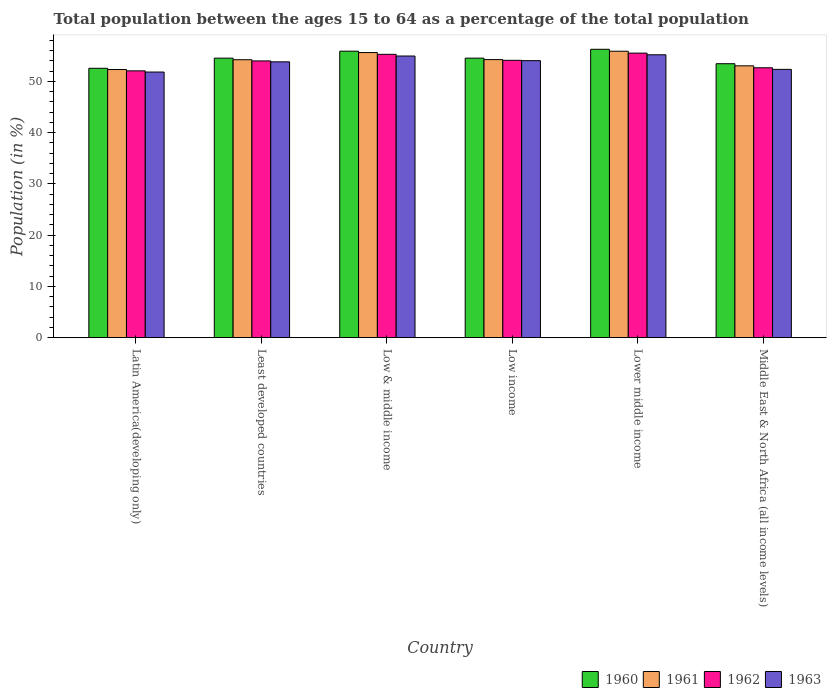How many different coloured bars are there?
Your answer should be very brief. 4. Are the number of bars on each tick of the X-axis equal?
Offer a terse response. Yes. What is the percentage of the population ages 15 to 64 in 1961 in Lower middle income?
Ensure brevity in your answer.  55.89. Across all countries, what is the maximum percentage of the population ages 15 to 64 in 1960?
Your response must be concise. 56.27. Across all countries, what is the minimum percentage of the population ages 15 to 64 in 1961?
Ensure brevity in your answer.  52.32. In which country was the percentage of the population ages 15 to 64 in 1960 maximum?
Your answer should be compact. Lower middle income. In which country was the percentage of the population ages 15 to 64 in 1961 minimum?
Offer a terse response. Latin America(developing only). What is the total percentage of the population ages 15 to 64 in 1961 in the graph?
Keep it short and to the point. 325.38. What is the difference between the percentage of the population ages 15 to 64 in 1960 in Latin America(developing only) and that in Least developed countries?
Your answer should be compact. -1.98. What is the difference between the percentage of the population ages 15 to 64 in 1962 in Low income and the percentage of the population ages 15 to 64 in 1960 in Least developed countries?
Your response must be concise. -0.43. What is the average percentage of the population ages 15 to 64 in 1962 per country?
Give a very brief answer. 53.94. What is the difference between the percentage of the population ages 15 to 64 of/in 1961 and percentage of the population ages 15 to 64 of/in 1960 in Low income?
Your answer should be compact. -0.28. In how many countries, is the percentage of the population ages 15 to 64 in 1960 greater than 30?
Provide a succinct answer. 6. What is the ratio of the percentage of the population ages 15 to 64 in 1961 in Latin America(developing only) to that in Low income?
Offer a very short reply. 0.96. Is the percentage of the population ages 15 to 64 in 1963 in Latin America(developing only) less than that in Lower middle income?
Your answer should be very brief. Yes. What is the difference between the highest and the second highest percentage of the population ages 15 to 64 in 1960?
Make the answer very short. 1.73. What is the difference between the highest and the lowest percentage of the population ages 15 to 64 in 1961?
Your answer should be compact. 3.57. In how many countries, is the percentage of the population ages 15 to 64 in 1960 greater than the average percentage of the population ages 15 to 64 in 1960 taken over all countries?
Provide a succinct answer. 2. What does the 3rd bar from the right in Low income represents?
Ensure brevity in your answer.  1961. Are all the bars in the graph horizontal?
Offer a very short reply. No. How many countries are there in the graph?
Give a very brief answer. 6. What is the difference between two consecutive major ticks on the Y-axis?
Your answer should be compact. 10. Are the values on the major ticks of Y-axis written in scientific E-notation?
Your answer should be compact. No. Does the graph contain any zero values?
Provide a short and direct response. No. Does the graph contain grids?
Make the answer very short. No. Where does the legend appear in the graph?
Your response must be concise. Bottom right. How are the legend labels stacked?
Ensure brevity in your answer.  Horizontal. What is the title of the graph?
Ensure brevity in your answer.  Total population between the ages 15 to 64 as a percentage of the total population. Does "1961" appear as one of the legend labels in the graph?
Give a very brief answer. Yes. What is the label or title of the X-axis?
Offer a terse response. Country. What is the label or title of the Y-axis?
Give a very brief answer. Population (in %). What is the Population (in %) of 1960 in Latin America(developing only)?
Ensure brevity in your answer.  52.56. What is the Population (in %) in 1961 in Latin America(developing only)?
Offer a terse response. 52.32. What is the Population (in %) in 1962 in Latin America(developing only)?
Keep it short and to the point. 52.06. What is the Population (in %) in 1963 in Latin America(developing only)?
Your answer should be compact. 51.83. What is the Population (in %) of 1960 in Least developed countries?
Ensure brevity in your answer.  54.54. What is the Population (in %) in 1961 in Least developed countries?
Give a very brief answer. 54.24. What is the Population (in %) of 1962 in Least developed countries?
Your answer should be compact. 54. What is the Population (in %) of 1963 in Least developed countries?
Your answer should be compact. 53.82. What is the Population (in %) in 1960 in Low & middle income?
Your response must be concise. 55.9. What is the Population (in %) of 1961 in Low & middle income?
Your response must be concise. 55.63. What is the Population (in %) of 1962 in Low & middle income?
Give a very brief answer. 55.29. What is the Population (in %) in 1963 in Low & middle income?
Provide a short and direct response. 54.96. What is the Population (in %) in 1960 in Low income?
Offer a very short reply. 54.54. What is the Population (in %) of 1961 in Low income?
Ensure brevity in your answer.  54.26. What is the Population (in %) of 1962 in Low income?
Give a very brief answer. 54.11. What is the Population (in %) in 1963 in Low income?
Your answer should be very brief. 54.06. What is the Population (in %) in 1960 in Lower middle income?
Keep it short and to the point. 56.27. What is the Population (in %) of 1961 in Lower middle income?
Your answer should be compact. 55.89. What is the Population (in %) of 1962 in Lower middle income?
Give a very brief answer. 55.53. What is the Population (in %) in 1963 in Lower middle income?
Your answer should be very brief. 55.2. What is the Population (in %) in 1960 in Middle East & North Africa (all income levels)?
Provide a short and direct response. 53.46. What is the Population (in %) in 1961 in Middle East & North Africa (all income levels)?
Give a very brief answer. 53.04. What is the Population (in %) of 1962 in Middle East & North Africa (all income levels)?
Provide a succinct answer. 52.67. What is the Population (in %) of 1963 in Middle East & North Africa (all income levels)?
Give a very brief answer. 52.35. Across all countries, what is the maximum Population (in %) of 1960?
Offer a terse response. 56.27. Across all countries, what is the maximum Population (in %) in 1961?
Offer a very short reply. 55.89. Across all countries, what is the maximum Population (in %) in 1962?
Your answer should be compact. 55.53. Across all countries, what is the maximum Population (in %) in 1963?
Your answer should be compact. 55.2. Across all countries, what is the minimum Population (in %) in 1960?
Make the answer very short. 52.56. Across all countries, what is the minimum Population (in %) of 1961?
Give a very brief answer. 52.32. Across all countries, what is the minimum Population (in %) of 1962?
Offer a terse response. 52.06. Across all countries, what is the minimum Population (in %) of 1963?
Your response must be concise. 51.83. What is the total Population (in %) of 1960 in the graph?
Give a very brief answer. 327.28. What is the total Population (in %) of 1961 in the graph?
Your response must be concise. 325.38. What is the total Population (in %) of 1962 in the graph?
Offer a terse response. 323.65. What is the total Population (in %) of 1963 in the graph?
Offer a terse response. 322.22. What is the difference between the Population (in %) of 1960 in Latin America(developing only) and that in Least developed countries?
Offer a terse response. -1.98. What is the difference between the Population (in %) of 1961 in Latin America(developing only) and that in Least developed countries?
Your response must be concise. -1.91. What is the difference between the Population (in %) of 1962 in Latin America(developing only) and that in Least developed countries?
Your answer should be very brief. -1.94. What is the difference between the Population (in %) of 1963 in Latin America(developing only) and that in Least developed countries?
Keep it short and to the point. -1.99. What is the difference between the Population (in %) of 1960 in Latin America(developing only) and that in Low & middle income?
Offer a terse response. -3.34. What is the difference between the Population (in %) in 1961 in Latin America(developing only) and that in Low & middle income?
Provide a short and direct response. -3.31. What is the difference between the Population (in %) in 1962 in Latin America(developing only) and that in Low & middle income?
Offer a very short reply. -3.22. What is the difference between the Population (in %) in 1963 in Latin America(developing only) and that in Low & middle income?
Offer a very short reply. -3.13. What is the difference between the Population (in %) of 1960 in Latin America(developing only) and that in Low income?
Provide a short and direct response. -1.98. What is the difference between the Population (in %) of 1961 in Latin America(developing only) and that in Low income?
Give a very brief answer. -1.94. What is the difference between the Population (in %) in 1962 in Latin America(developing only) and that in Low income?
Offer a terse response. -2.05. What is the difference between the Population (in %) in 1963 in Latin America(developing only) and that in Low income?
Offer a terse response. -2.22. What is the difference between the Population (in %) in 1960 in Latin America(developing only) and that in Lower middle income?
Give a very brief answer. -3.71. What is the difference between the Population (in %) of 1961 in Latin America(developing only) and that in Lower middle income?
Offer a very short reply. -3.57. What is the difference between the Population (in %) of 1962 in Latin America(developing only) and that in Lower middle income?
Ensure brevity in your answer.  -3.46. What is the difference between the Population (in %) of 1963 in Latin America(developing only) and that in Lower middle income?
Provide a short and direct response. -3.37. What is the difference between the Population (in %) in 1960 in Latin America(developing only) and that in Middle East & North Africa (all income levels)?
Offer a terse response. -0.89. What is the difference between the Population (in %) of 1961 in Latin America(developing only) and that in Middle East & North Africa (all income levels)?
Your answer should be very brief. -0.72. What is the difference between the Population (in %) of 1962 in Latin America(developing only) and that in Middle East & North Africa (all income levels)?
Give a very brief answer. -0.6. What is the difference between the Population (in %) of 1963 in Latin America(developing only) and that in Middle East & North Africa (all income levels)?
Ensure brevity in your answer.  -0.52. What is the difference between the Population (in %) in 1960 in Least developed countries and that in Low & middle income?
Ensure brevity in your answer.  -1.36. What is the difference between the Population (in %) of 1961 in Least developed countries and that in Low & middle income?
Provide a short and direct response. -1.39. What is the difference between the Population (in %) of 1962 in Least developed countries and that in Low & middle income?
Your answer should be compact. -1.29. What is the difference between the Population (in %) of 1963 in Least developed countries and that in Low & middle income?
Offer a terse response. -1.13. What is the difference between the Population (in %) in 1960 in Least developed countries and that in Low income?
Offer a very short reply. 0. What is the difference between the Population (in %) of 1961 in Least developed countries and that in Low income?
Offer a very short reply. -0.02. What is the difference between the Population (in %) in 1962 in Least developed countries and that in Low income?
Give a very brief answer. -0.12. What is the difference between the Population (in %) in 1963 in Least developed countries and that in Low income?
Keep it short and to the point. -0.23. What is the difference between the Population (in %) of 1960 in Least developed countries and that in Lower middle income?
Your answer should be compact. -1.73. What is the difference between the Population (in %) in 1961 in Least developed countries and that in Lower middle income?
Make the answer very short. -1.66. What is the difference between the Population (in %) of 1962 in Least developed countries and that in Lower middle income?
Provide a succinct answer. -1.53. What is the difference between the Population (in %) of 1963 in Least developed countries and that in Lower middle income?
Make the answer very short. -1.38. What is the difference between the Population (in %) in 1960 in Least developed countries and that in Middle East & North Africa (all income levels)?
Your response must be concise. 1.09. What is the difference between the Population (in %) of 1961 in Least developed countries and that in Middle East & North Africa (all income levels)?
Give a very brief answer. 1.19. What is the difference between the Population (in %) in 1962 in Least developed countries and that in Middle East & North Africa (all income levels)?
Your answer should be very brief. 1.33. What is the difference between the Population (in %) of 1963 in Least developed countries and that in Middle East & North Africa (all income levels)?
Offer a very short reply. 1.47. What is the difference between the Population (in %) of 1960 in Low & middle income and that in Low income?
Your response must be concise. 1.36. What is the difference between the Population (in %) of 1961 in Low & middle income and that in Low income?
Your answer should be very brief. 1.37. What is the difference between the Population (in %) of 1962 in Low & middle income and that in Low income?
Your answer should be compact. 1.17. What is the difference between the Population (in %) in 1963 in Low & middle income and that in Low income?
Provide a short and direct response. 0.9. What is the difference between the Population (in %) in 1960 in Low & middle income and that in Lower middle income?
Provide a succinct answer. -0.37. What is the difference between the Population (in %) of 1961 in Low & middle income and that in Lower middle income?
Your response must be concise. -0.26. What is the difference between the Population (in %) of 1962 in Low & middle income and that in Lower middle income?
Provide a short and direct response. -0.24. What is the difference between the Population (in %) of 1963 in Low & middle income and that in Lower middle income?
Provide a short and direct response. -0.24. What is the difference between the Population (in %) of 1960 in Low & middle income and that in Middle East & North Africa (all income levels)?
Provide a short and direct response. 2.45. What is the difference between the Population (in %) of 1961 in Low & middle income and that in Middle East & North Africa (all income levels)?
Offer a terse response. 2.59. What is the difference between the Population (in %) in 1962 in Low & middle income and that in Middle East & North Africa (all income levels)?
Give a very brief answer. 2.62. What is the difference between the Population (in %) of 1963 in Low & middle income and that in Middle East & North Africa (all income levels)?
Your response must be concise. 2.6. What is the difference between the Population (in %) in 1960 in Low income and that in Lower middle income?
Give a very brief answer. -1.73. What is the difference between the Population (in %) in 1961 in Low income and that in Lower middle income?
Your answer should be compact. -1.63. What is the difference between the Population (in %) in 1962 in Low income and that in Lower middle income?
Offer a very short reply. -1.41. What is the difference between the Population (in %) in 1963 in Low income and that in Lower middle income?
Keep it short and to the point. -1.14. What is the difference between the Population (in %) of 1960 in Low income and that in Middle East & North Africa (all income levels)?
Your response must be concise. 1.08. What is the difference between the Population (in %) in 1961 in Low income and that in Middle East & North Africa (all income levels)?
Give a very brief answer. 1.22. What is the difference between the Population (in %) in 1962 in Low income and that in Middle East & North Africa (all income levels)?
Provide a succinct answer. 1.45. What is the difference between the Population (in %) of 1963 in Low income and that in Middle East & North Africa (all income levels)?
Provide a short and direct response. 1.7. What is the difference between the Population (in %) in 1960 in Lower middle income and that in Middle East & North Africa (all income levels)?
Offer a very short reply. 2.81. What is the difference between the Population (in %) of 1961 in Lower middle income and that in Middle East & North Africa (all income levels)?
Provide a short and direct response. 2.85. What is the difference between the Population (in %) in 1962 in Lower middle income and that in Middle East & North Africa (all income levels)?
Ensure brevity in your answer.  2.86. What is the difference between the Population (in %) of 1963 in Lower middle income and that in Middle East & North Africa (all income levels)?
Your answer should be very brief. 2.85. What is the difference between the Population (in %) of 1960 in Latin America(developing only) and the Population (in %) of 1961 in Least developed countries?
Provide a succinct answer. -1.67. What is the difference between the Population (in %) of 1960 in Latin America(developing only) and the Population (in %) of 1962 in Least developed countries?
Your answer should be very brief. -1.44. What is the difference between the Population (in %) of 1960 in Latin America(developing only) and the Population (in %) of 1963 in Least developed countries?
Your response must be concise. -1.26. What is the difference between the Population (in %) in 1961 in Latin America(developing only) and the Population (in %) in 1962 in Least developed countries?
Ensure brevity in your answer.  -1.68. What is the difference between the Population (in %) in 1961 in Latin America(developing only) and the Population (in %) in 1963 in Least developed countries?
Keep it short and to the point. -1.5. What is the difference between the Population (in %) in 1962 in Latin America(developing only) and the Population (in %) in 1963 in Least developed countries?
Your response must be concise. -1.76. What is the difference between the Population (in %) of 1960 in Latin America(developing only) and the Population (in %) of 1961 in Low & middle income?
Give a very brief answer. -3.07. What is the difference between the Population (in %) in 1960 in Latin America(developing only) and the Population (in %) in 1962 in Low & middle income?
Your response must be concise. -2.72. What is the difference between the Population (in %) of 1960 in Latin America(developing only) and the Population (in %) of 1963 in Low & middle income?
Provide a succinct answer. -2.39. What is the difference between the Population (in %) of 1961 in Latin America(developing only) and the Population (in %) of 1962 in Low & middle income?
Ensure brevity in your answer.  -2.96. What is the difference between the Population (in %) of 1961 in Latin America(developing only) and the Population (in %) of 1963 in Low & middle income?
Offer a terse response. -2.63. What is the difference between the Population (in %) of 1962 in Latin America(developing only) and the Population (in %) of 1963 in Low & middle income?
Provide a short and direct response. -2.89. What is the difference between the Population (in %) in 1960 in Latin America(developing only) and the Population (in %) in 1961 in Low income?
Offer a very short reply. -1.7. What is the difference between the Population (in %) of 1960 in Latin America(developing only) and the Population (in %) of 1962 in Low income?
Ensure brevity in your answer.  -1.55. What is the difference between the Population (in %) in 1960 in Latin America(developing only) and the Population (in %) in 1963 in Low income?
Ensure brevity in your answer.  -1.49. What is the difference between the Population (in %) of 1961 in Latin America(developing only) and the Population (in %) of 1962 in Low income?
Your answer should be compact. -1.79. What is the difference between the Population (in %) in 1961 in Latin America(developing only) and the Population (in %) in 1963 in Low income?
Provide a short and direct response. -1.73. What is the difference between the Population (in %) of 1962 in Latin America(developing only) and the Population (in %) of 1963 in Low income?
Offer a terse response. -1.99. What is the difference between the Population (in %) of 1960 in Latin America(developing only) and the Population (in %) of 1961 in Lower middle income?
Your answer should be very brief. -3.33. What is the difference between the Population (in %) of 1960 in Latin America(developing only) and the Population (in %) of 1962 in Lower middle income?
Offer a very short reply. -2.96. What is the difference between the Population (in %) of 1960 in Latin America(developing only) and the Population (in %) of 1963 in Lower middle income?
Keep it short and to the point. -2.64. What is the difference between the Population (in %) of 1961 in Latin America(developing only) and the Population (in %) of 1962 in Lower middle income?
Give a very brief answer. -3.2. What is the difference between the Population (in %) of 1961 in Latin America(developing only) and the Population (in %) of 1963 in Lower middle income?
Offer a terse response. -2.88. What is the difference between the Population (in %) in 1962 in Latin America(developing only) and the Population (in %) in 1963 in Lower middle income?
Offer a very short reply. -3.14. What is the difference between the Population (in %) in 1960 in Latin America(developing only) and the Population (in %) in 1961 in Middle East & North Africa (all income levels)?
Offer a terse response. -0.48. What is the difference between the Population (in %) of 1960 in Latin America(developing only) and the Population (in %) of 1962 in Middle East & North Africa (all income levels)?
Keep it short and to the point. -0.1. What is the difference between the Population (in %) of 1960 in Latin America(developing only) and the Population (in %) of 1963 in Middle East & North Africa (all income levels)?
Your answer should be very brief. 0.21. What is the difference between the Population (in %) of 1961 in Latin America(developing only) and the Population (in %) of 1962 in Middle East & North Africa (all income levels)?
Your response must be concise. -0.34. What is the difference between the Population (in %) in 1961 in Latin America(developing only) and the Population (in %) in 1963 in Middle East & North Africa (all income levels)?
Offer a very short reply. -0.03. What is the difference between the Population (in %) of 1962 in Latin America(developing only) and the Population (in %) of 1963 in Middle East & North Africa (all income levels)?
Your answer should be very brief. -0.29. What is the difference between the Population (in %) of 1960 in Least developed countries and the Population (in %) of 1961 in Low & middle income?
Your response must be concise. -1.09. What is the difference between the Population (in %) in 1960 in Least developed countries and the Population (in %) in 1962 in Low & middle income?
Your answer should be very brief. -0.74. What is the difference between the Population (in %) in 1960 in Least developed countries and the Population (in %) in 1963 in Low & middle income?
Offer a very short reply. -0.42. What is the difference between the Population (in %) in 1961 in Least developed countries and the Population (in %) in 1962 in Low & middle income?
Offer a terse response. -1.05. What is the difference between the Population (in %) in 1961 in Least developed countries and the Population (in %) in 1963 in Low & middle income?
Your answer should be very brief. -0.72. What is the difference between the Population (in %) in 1962 in Least developed countries and the Population (in %) in 1963 in Low & middle income?
Provide a short and direct response. -0.96. What is the difference between the Population (in %) of 1960 in Least developed countries and the Population (in %) of 1961 in Low income?
Ensure brevity in your answer.  0.28. What is the difference between the Population (in %) in 1960 in Least developed countries and the Population (in %) in 1962 in Low income?
Make the answer very short. 0.43. What is the difference between the Population (in %) of 1960 in Least developed countries and the Population (in %) of 1963 in Low income?
Your answer should be very brief. 0.49. What is the difference between the Population (in %) of 1961 in Least developed countries and the Population (in %) of 1962 in Low income?
Provide a succinct answer. 0.12. What is the difference between the Population (in %) in 1961 in Least developed countries and the Population (in %) in 1963 in Low income?
Ensure brevity in your answer.  0.18. What is the difference between the Population (in %) in 1962 in Least developed countries and the Population (in %) in 1963 in Low income?
Provide a short and direct response. -0.06. What is the difference between the Population (in %) of 1960 in Least developed countries and the Population (in %) of 1961 in Lower middle income?
Make the answer very short. -1.35. What is the difference between the Population (in %) of 1960 in Least developed countries and the Population (in %) of 1962 in Lower middle income?
Your response must be concise. -0.98. What is the difference between the Population (in %) of 1960 in Least developed countries and the Population (in %) of 1963 in Lower middle income?
Keep it short and to the point. -0.66. What is the difference between the Population (in %) in 1961 in Least developed countries and the Population (in %) in 1962 in Lower middle income?
Keep it short and to the point. -1.29. What is the difference between the Population (in %) of 1961 in Least developed countries and the Population (in %) of 1963 in Lower middle income?
Keep it short and to the point. -0.96. What is the difference between the Population (in %) in 1962 in Least developed countries and the Population (in %) in 1963 in Lower middle income?
Offer a terse response. -1.2. What is the difference between the Population (in %) in 1960 in Least developed countries and the Population (in %) in 1961 in Middle East & North Africa (all income levels)?
Your response must be concise. 1.5. What is the difference between the Population (in %) of 1960 in Least developed countries and the Population (in %) of 1962 in Middle East & North Africa (all income levels)?
Offer a terse response. 1.88. What is the difference between the Population (in %) of 1960 in Least developed countries and the Population (in %) of 1963 in Middle East & North Africa (all income levels)?
Your response must be concise. 2.19. What is the difference between the Population (in %) in 1961 in Least developed countries and the Population (in %) in 1962 in Middle East & North Africa (all income levels)?
Keep it short and to the point. 1.57. What is the difference between the Population (in %) in 1961 in Least developed countries and the Population (in %) in 1963 in Middle East & North Africa (all income levels)?
Provide a short and direct response. 1.88. What is the difference between the Population (in %) of 1962 in Least developed countries and the Population (in %) of 1963 in Middle East & North Africa (all income levels)?
Your answer should be very brief. 1.65. What is the difference between the Population (in %) of 1960 in Low & middle income and the Population (in %) of 1961 in Low income?
Your answer should be compact. 1.64. What is the difference between the Population (in %) of 1960 in Low & middle income and the Population (in %) of 1962 in Low income?
Make the answer very short. 1.79. What is the difference between the Population (in %) in 1960 in Low & middle income and the Population (in %) in 1963 in Low income?
Give a very brief answer. 1.85. What is the difference between the Population (in %) in 1961 in Low & middle income and the Population (in %) in 1962 in Low income?
Provide a succinct answer. 1.51. What is the difference between the Population (in %) of 1961 in Low & middle income and the Population (in %) of 1963 in Low income?
Offer a terse response. 1.57. What is the difference between the Population (in %) of 1962 in Low & middle income and the Population (in %) of 1963 in Low income?
Ensure brevity in your answer.  1.23. What is the difference between the Population (in %) in 1960 in Low & middle income and the Population (in %) in 1961 in Lower middle income?
Provide a succinct answer. 0.01. What is the difference between the Population (in %) in 1960 in Low & middle income and the Population (in %) in 1962 in Lower middle income?
Provide a succinct answer. 0.38. What is the difference between the Population (in %) of 1960 in Low & middle income and the Population (in %) of 1963 in Lower middle income?
Give a very brief answer. 0.7. What is the difference between the Population (in %) of 1961 in Low & middle income and the Population (in %) of 1962 in Lower middle income?
Your answer should be compact. 0.1. What is the difference between the Population (in %) of 1961 in Low & middle income and the Population (in %) of 1963 in Lower middle income?
Provide a short and direct response. 0.43. What is the difference between the Population (in %) of 1962 in Low & middle income and the Population (in %) of 1963 in Lower middle income?
Your answer should be very brief. 0.09. What is the difference between the Population (in %) in 1960 in Low & middle income and the Population (in %) in 1961 in Middle East & North Africa (all income levels)?
Your answer should be very brief. 2.86. What is the difference between the Population (in %) in 1960 in Low & middle income and the Population (in %) in 1962 in Middle East & North Africa (all income levels)?
Make the answer very short. 3.24. What is the difference between the Population (in %) of 1960 in Low & middle income and the Population (in %) of 1963 in Middle East & North Africa (all income levels)?
Ensure brevity in your answer.  3.55. What is the difference between the Population (in %) in 1961 in Low & middle income and the Population (in %) in 1962 in Middle East & North Africa (all income levels)?
Your answer should be compact. 2.96. What is the difference between the Population (in %) of 1961 in Low & middle income and the Population (in %) of 1963 in Middle East & North Africa (all income levels)?
Ensure brevity in your answer.  3.28. What is the difference between the Population (in %) in 1962 in Low & middle income and the Population (in %) in 1963 in Middle East & North Africa (all income levels)?
Offer a very short reply. 2.93. What is the difference between the Population (in %) in 1960 in Low income and the Population (in %) in 1961 in Lower middle income?
Keep it short and to the point. -1.35. What is the difference between the Population (in %) of 1960 in Low income and the Population (in %) of 1962 in Lower middle income?
Provide a succinct answer. -0.98. What is the difference between the Population (in %) in 1960 in Low income and the Population (in %) in 1963 in Lower middle income?
Provide a short and direct response. -0.66. What is the difference between the Population (in %) in 1961 in Low income and the Population (in %) in 1962 in Lower middle income?
Make the answer very short. -1.27. What is the difference between the Population (in %) in 1961 in Low income and the Population (in %) in 1963 in Lower middle income?
Give a very brief answer. -0.94. What is the difference between the Population (in %) in 1962 in Low income and the Population (in %) in 1963 in Lower middle income?
Provide a succinct answer. -1.09. What is the difference between the Population (in %) in 1960 in Low income and the Population (in %) in 1961 in Middle East & North Africa (all income levels)?
Your answer should be compact. 1.5. What is the difference between the Population (in %) in 1960 in Low income and the Population (in %) in 1962 in Middle East & North Africa (all income levels)?
Give a very brief answer. 1.88. What is the difference between the Population (in %) of 1960 in Low income and the Population (in %) of 1963 in Middle East & North Africa (all income levels)?
Offer a terse response. 2.19. What is the difference between the Population (in %) in 1961 in Low income and the Population (in %) in 1962 in Middle East & North Africa (all income levels)?
Keep it short and to the point. 1.59. What is the difference between the Population (in %) of 1961 in Low income and the Population (in %) of 1963 in Middle East & North Africa (all income levels)?
Provide a succinct answer. 1.91. What is the difference between the Population (in %) of 1962 in Low income and the Population (in %) of 1963 in Middle East & North Africa (all income levels)?
Offer a terse response. 1.76. What is the difference between the Population (in %) in 1960 in Lower middle income and the Population (in %) in 1961 in Middle East & North Africa (all income levels)?
Offer a very short reply. 3.23. What is the difference between the Population (in %) in 1960 in Lower middle income and the Population (in %) in 1962 in Middle East & North Africa (all income levels)?
Your response must be concise. 3.6. What is the difference between the Population (in %) of 1960 in Lower middle income and the Population (in %) of 1963 in Middle East & North Africa (all income levels)?
Give a very brief answer. 3.92. What is the difference between the Population (in %) in 1961 in Lower middle income and the Population (in %) in 1962 in Middle East & North Africa (all income levels)?
Keep it short and to the point. 3.23. What is the difference between the Population (in %) in 1961 in Lower middle income and the Population (in %) in 1963 in Middle East & North Africa (all income levels)?
Your answer should be very brief. 3.54. What is the difference between the Population (in %) in 1962 in Lower middle income and the Population (in %) in 1963 in Middle East & North Africa (all income levels)?
Offer a very short reply. 3.17. What is the average Population (in %) in 1960 per country?
Offer a very short reply. 54.55. What is the average Population (in %) of 1961 per country?
Offer a terse response. 54.23. What is the average Population (in %) of 1962 per country?
Provide a short and direct response. 53.94. What is the average Population (in %) in 1963 per country?
Provide a succinct answer. 53.7. What is the difference between the Population (in %) in 1960 and Population (in %) in 1961 in Latin America(developing only)?
Provide a succinct answer. 0.24. What is the difference between the Population (in %) in 1960 and Population (in %) in 1962 in Latin America(developing only)?
Your response must be concise. 0.5. What is the difference between the Population (in %) of 1960 and Population (in %) of 1963 in Latin America(developing only)?
Provide a short and direct response. 0.73. What is the difference between the Population (in %) of 1961 and Population (in %) of 1962 in Latin America(developing only)?
Make the answer very short. 0.26. What is the difference between the Population (in %) of 1961 and Population (in %) of 1963 in Latin America(developing only)?
Give a very brief answer. 0.49. What is the difference between the Population (in %) in 1962 and Population (in %) in 1963 in Latin America(developing only)?
Your answer should be very brief. 0.23. What is the difference between the Population (in %) of 1960 and Population (in %) of 1961 in Least developed countries?
Your response must be concise. 0.31. What is the difference between the Population (in %) in 1960 and Population (in %) in 1962 in Least developed countries?
Give a very brief answer. 0.54. What is the difference between the Population (in %) in 1960 and Population (in %) in 1963 in Least developed countries?
Your response must be concise. 0.72. What is the difference between the Population (in %) of 1961 and Population (in %) of 1962 in Least developed countries?
Give a very brief answer. 0.24. What is the difference between the Population (in %) of 1961 and Population (in %) of 1963 in Least developed countries?
Provide a short and direct response. 0.41. What is the difference between the Population (in %) of 1962 and Population (in %) of 1963 in Least developed countries?
Provide a short and direct response. 0.18. What is the difference between the Population (in %) in 1960 and Population (in %) in 1961 in Low & middle income?
Ensure brevity in your answer.  0.27. What is the difference between the Population (in %) in 1960 and Population (in %) in 1962 in Low & middle income?
Your answer should be very brief. 0.62. What is the difference between the Population (in %) of 1960 and Population (in %) of 1963 in Low & middle income?
Offer a very short reply. 0.95. What is the difference between the Population (in %) of 1961 and Population (in %) of 1962 in Low & middle income?
Offer a very short reply. 0.34. What is the difference between the Population (in %) in 1961 and Population (in %) in 1963 in Low & middle income?
Make the answer very short. 0.67. What is the difference between the Population (in %) of 1962 and Population (in %) of 1963 in Low & middle income?
Give a very brief answer. 0.33. What is the difference between the Population (in %) in 1960 and Population (in %) in 1961 in Low income?
Provide a succinct answer. 0.28. What is the difference between the Population (in %) in 1960 and Population (in %) in 1962 in Low income?
Your answer should be very brief. 0.43. What is the difference between the Population (in %) of 1960 and Population (in %) of 1963 in Low income?
Ensure brevity in your answer.  0.49. What is the difference between the Population (in %) of 1961 and Population (in %) of 1962 in Low income?
Offer a terse response. 0.14. What is the difference between the Population (in %) of 1961 and Population (in %) of 1963 in Low income?
Offer a very short reply. 0.2. What is the difference between the Population (in %) in 1962 and Population (in %) in 1963 in Low income?
Your response must be concise. 0.06. What is the difference between the Population (in %) in 1960 and Population (in %) in 1961 in Lower middle income?
Offer a very short reply. 0.38. What is the difference between the Population (in %) in 1960 and Population (in %) in 1962 in Lower middle income?
Offer a terse response. 0.74. What is the difference between the Population (in %) in 1960 and Population (in %) in 1963 in Lower middle income?
Offer a very short reply. 1.07. What is the difference between the Population (in %) in 1961 and Population (in %) in 1962 in Lower middle income?
Offer a terse response. 0.37. What is the difference between the Population (in %) of 1961 and Population (in %) of 1963 in Lower middle income?
Your answer should be compact. 0.69. What is the difference between the Population (in %) of 1962 and Population (in %) of 1963 in Lower middle income?
Ensure brevity in your answer.  0.33. What is the difference between the Population (in %) of 1960 and Population (in %) of 1961 in Middle East & North Africa (all income levels)?
Offer a very short reply. 0.42. What is the difference between the Population (in %) in 1960 and Population (in %) in 1962 in Middle East & North Africa (all income levels)?
Keep it short and to the point. 0.79. What is the difference between the Population (in %) of 1960 and Population (in %) of 1963 in Middle East & North Africa (all income levels)?
Keep it short and to the point. 1.1. What is the difference between the Population (in %) in 1961 and Population (in %) in 1962 in Middle East & North Africa (all income levels)?
Provide a short and direct response. 0.38. What is the difference between the Population (in %) in 1961 and Population (in %) in 1963 in Middle East & North Africa (all income levels)?
Make the answer very short. 0.69. What is the difference between the Population (in %) of 1962 and Population (in %) of 1963 in Middle East & North Africa (all income levels)?
Provide a succinct answer. 0.31. What is the ratio of the Population (in %) of 1960 in Latin America(developing only) to that in Least developed countries?
Your response must be concise. 0.96. What is the ratio of the Population (in %) of 1961 in Latin America(developing only) to that in Least developed countries?
Your answer should be compact. 0.96. What is the ratio of the Population (in %) in 1962 in Latin America(developing only) to that in Least developed countries?
Keep it short and to the point. 0.96. What is the ratio of the Population (in %) in 1963 in Latin America(developing only) to that in Least developed countries?
Provide a short and direct response. 0.96. What is the ratio of the Population (in %) in 1960 in Latin America(developing only) to that in Low & middle income?
Your response must be concise. 0.94. What is the ratio of the Population (in %) of 1961 in Latin America(developing only) to that in Low & middle income?
Ensure brevity in your answer.  0.94. What is the ratio of the Population (in %) of 1962 in Latin America(developing only) to that in Low & middle income?
Your answer should be compact. 0.94. What is the ratio of the Population (in %) in 1963 in Latin America(developing only) to that in Low & middle income?
Make the answer very short. 0.94. What is the ratio of the Population (in %) in 1960 in Latin America(developing only) to that in Low income?
Your answer should be very brief. 0.96. What is the ratio of the Population (in %) of 1961 in Latin America(developing only) to that in Low income?
Give a very brief answer. 0.96. What is the ratio of the Population (in %) of 1962 in Latin America(developing only) to that in Low income?
Your answer should be compact. 0.96. What is the ratio of the Population (in %) in 1963 in Latin America(developing only) to that in Low income?
Your answer should be compact. 0.96. What is the ratio of the Population (in %) of 1960 in Latin America(developing only) to that in Lower middle income?
Give a very brief answer. 0.93. What is the ratio of the Population (in %) of 1961 in Latin America(developing only) to that in Lower middle income?
Your answer should be compact. 0.94. What is the ratio of the Population (in %) of 1962 in Latin America(developing only) to that in Lower middle income?
Give a very brief answer. 0.94. What is the ratio of the Population (in %) in 1963 in Latin America(developing only) to that in Lower middle income?
Keep it short and to the point. 0.94. What is the ratio of the Population (in %) in 1960 in Latin America(developing only) to that in Middle East & North Africa (all income levels)?
Ensure brevity in your answer.  0.98. What is the ratio of the Population (in %) in 1961 in Latin America(developing only) to that in Middle East & North Africa (all income levels)?
Provide a succinct answer. 0.99. What is the ratio of the Population (in %) of 1962 in Latin America(developing only) to that in Middle East & North Africa (all income levels)?
Your response must be concise. 0.99. What is the ratio of the Population (in %) in 1960 in Least developed countries to that in Low & middle income?
Offer a very short reply. 0.98. What is the ratio of the Population (in %) in 1961 in Least developed countries to that in Low & middle income?
Provide a succinct answer. 0.97. What is the ratio of the Population (in %) in 1962 in Least developed countries to that in Low & middle income?
Offer a terse response. 0.98. What is the ratio of the Population (in %) in 1963 in Least developed countries to that in Low & middle income?
Make the answer very short. 0.98. What is the ratio of the Population (in %) of 1960 in Least developed countries to that in Low income?
Your answer should be very brief. 1. What is the ratio of the Population (in %) of 1963 in Least developed countries to that in Low income?
Give a very brief answer. 1. What is the ratio of the Population (in %) of 1960 in Least developed countries to that in Lower middle income?
Offer a very short reply. 0.97. What is the ratio of the Population (in %) in 1961 in Least developed countries to that in Lower middle income?
Give a very brief answer. 0.97. What is the ratio of the Population (in %) of 1962 in Least developed countries to that in Lower middle income?
Keep it short and to the point. 0.97. What is the ratio of the Population (in %) of 1963 in Least developed countries to that in Lower middle income?
Your answer should be compact. 0.97. What is the ratio of the Population (in %) in 1960 in Least developed countries to that in Middle East & North Africa (all income levels)?
Provide a short and direct response. 1.02. What is the ratio of the Population (in %) in 1961 in Least developed countries to that in Middle East & North Africa (all income levels)?
Your answer should be compact. 1.02. What is the ratio of the Population (in %) of 1962 in Least developed countries to that in Middle East & North Africa (all income levels)?
Provide a succinct answer. 1.03. What is the ratio of the Population (in %) of 1963 in Least developed countries to that in Middle East & North Africa (all income levels)?
Provide a short and direct response. 1.03. What is the ratio of the Population (in %) of 1960 in Low & middle income to that in Low income?
Offer a very short reply. 1.02. What is the ratio of the Population (in %) of 1961 in Low & middle income to that in Low income?
Provide a succinct answer. 1.03. What is the ratio of the Population (in %) of 1962 in Low & middle income to that in Low income?
Ensure brevity in your answer.  1.02. What is the ratio of the Population (in %) of 1963 in Low & middle income to that in Low income?
Provide a succinct answer. 1.02. What is the ratio of the Population (in %) in 1961 in Low & middle income to that in Lower middle income?
Your answer should be very brief. 1. What is the ratio of the Population (in %) of 1962 in Low & middle income to that in Lower middle income?
Keep it short and to the point. 1. What is the ratio of the Population (in %) of 1963 in Low & middle income to that in Lower middle income?
Make the answer very short. 1. What is the ratio of the Population (in %) in 1960 in Low & middle income to that in Middle East & North Africa (all income levels)?
Provide a short and direct response. 1.05. What is the ratio of the Population (in %) of 1961 in Low & middle income to that in Middle East & North Africa (all income levels)?
Ensure brevity in your answer.  1.05. What is the ratio of the Population (in %) in 1962 in Low & middle income to that in Middle East & North Africa (all income levels)?
Your answer should be very brief. 1.05. What is the ratio of the Population (in %) in 1963 in Low & middle income to that in Middle East & North Africa (all income levels)?
Your answer should be compact. 1.05. What is the ratio of the Population (in %) of 1960 in Low income to that in Lower middle income?
Provide a short and direct response. 0.97. What is the ratio of the Population (in %) of 1961 in Low income to that in Lower middle income?
Provide a short and direct response. 0.97. What is the ratio of the Population (in %) of 1962 in Low income to that in Lower middle income?
Make the answer very short. 0.97. What is the ratio of the Population (in %) in 1963 in Low income to that in Lower middle income?
Your answer should be very brief. 0.98. What is the ratio of the Population (in %) of 1960 in Low income to that in Middle East & North Africa (all income levels)?
Keep it short and to the point. 1.02. What is the ratio of the Population (in %) in 1961 in Low income to that in Middle East & North Africa (all income levels)?
Offer a terse response. 1.02. What is the ratio of the Population (in %) of 1962 in Low income to that in Middle East & North Africa (all income levels)?
Offer a terse response. 1.03. What is the ratio of the Population (in %) of 1963 in Low income to that in Middle East & North Africa (all income levels)?
Your answer should be compact. 1.03. What is the ratio of the Population (in %) in 1960 in Lower middle income to that in Middle East & North Africa (all income levels)?
Ensure brevity in your answer.  1.05. What is the ratio of the Population (in %) in 1961 in Lower middle income to that in Middle East & North Africa (all income levels)?
Offer a very short reply. 1.05. What is the ratio of the Population (in %) in 1962 in Lower middle income to that in Middle East & North Africa (all income levels)?
Your response must be concise. 1.05. What is the ratio of the Population (in %) of 1963 in Lower middle income to that in Middle East & North Africa (all income levels)?
Provide a succinct answer. 1.05. What is the difference between the highest and the second highest Population (in %) of 1960?
Your answer should be compact. 0.37. What is the difference between the highest and the second highest Population (in %) of 1961?
Your answer should be very brief. 0.26. What is the difference between the highest and the second highest Population (in %) of 1962?
Your answer should be compact. 0.24. What is the difference between the highest and the second highest Population (in %) of 1963?
Give a very brief answer. 0.24. What is the difference between the highest and the lowest Population (in %) in 1960?
Give a very brief answer. 3.71. What is the difference between the highest and the lowest Population (in %) in 1961?
Provide a short and direct response. 3.57. What is the difference between the highest and the lowest Population (in %) in 1962?
Offer a terse response. 3.46. What is the difference between the highest and the lowest Population (in %) in 1963?
Make the answer very short. 3.37. 